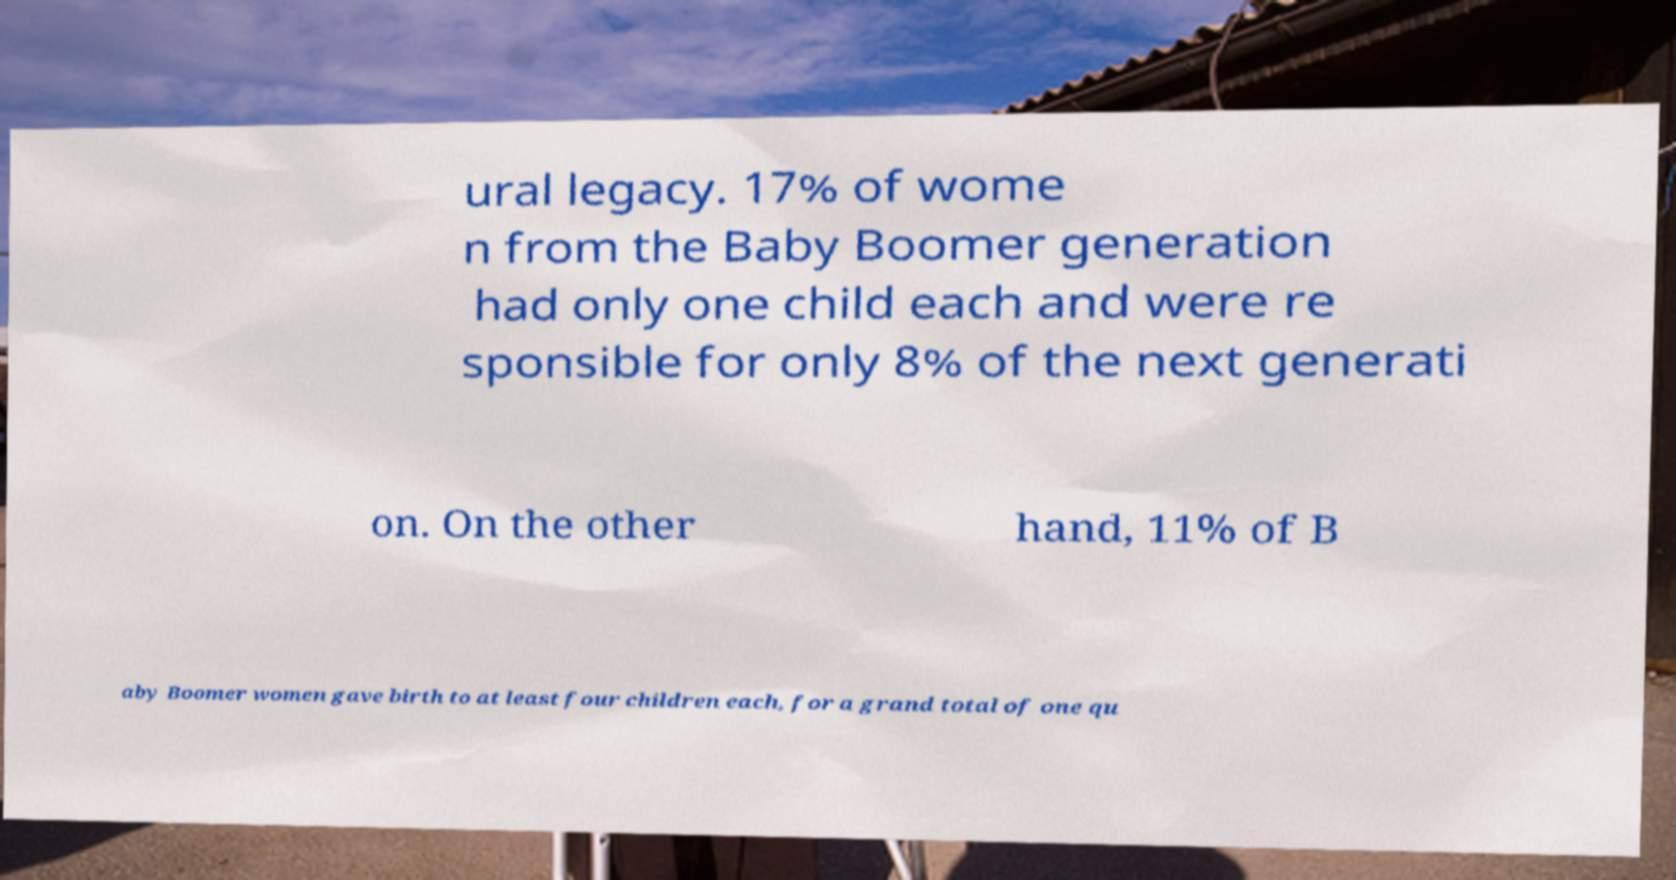Can you read and provide the text displayed in the image?This photo seems to have some interesting text. Can you extract and type it out for me? ural legacy. 17% of wome n from the Baby Boomer generation had only one child each and were re sponsible for only 8% of the next generati on. On the other hand, 11% of B aby Boomer women gave birth to at least four children each, for a grand total of one qu 